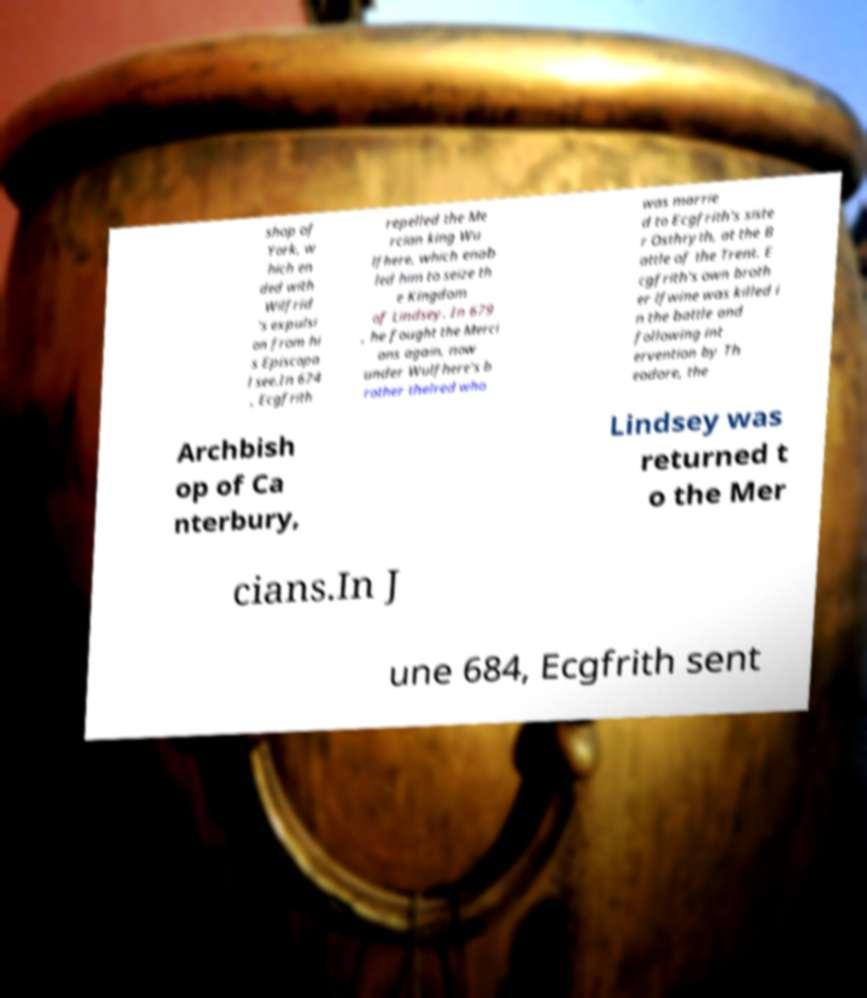Could you extract and type out the text from this image? shop of York, w hich en ded with Wilfrid 's expulsi on from hi s Episcopa l see.In 674 , Ecgfrith repelled the Me rcian king Wu lfhere, which enab led him to seize th e Kingdom of Lindsey. In 679 , he fought the Merci ans again, now under Wulfhere's b rother thelred who was marrie d to Ecgfrith's siste r Osthryth, at the B attle of the Trent. E cgfrith's own broth er lfwine was killed i n the battle and following int ervention by Th eodore, the Archbish op of Ca nterbury, Lindsey was returned t o the Mer cians.In J une 684, Ecgfrith sent 